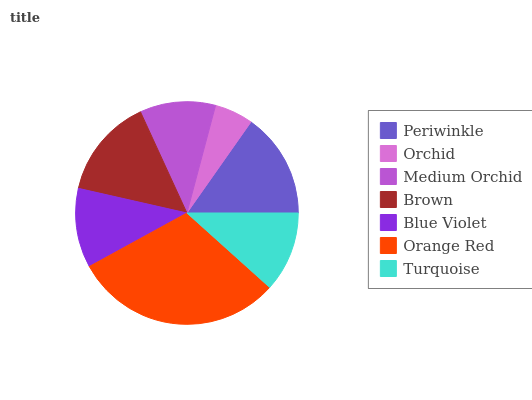Is Orchid the minimum?
Answer yes or no. Yes. Is Orange Red the maximum?
Answer yes or no. Yes. Is Medium Orchid the minimum?
Answer yes or no. No. Is Medium Orchid the maximum?
Answer yes or no. No. Is Medium Orchid greater than Orchid?
Answer yes or no. Yes. Is Orchid less than Medium Orchid?
Answer yes or no. Yes. Is Orchid greater than Medium Orchid?
Answer yes or no. No. Is Medium Orchid less than Orchid?
Answer yes or no. No. Is Turquoise the high median?
Answer yes or no. Yes. Is Turquoise the low median?
Answer yes or no. Yes. Is Blue Violet the high median?
Answer yes or no. No. Is Blue Violet the low median?
Answer yes or no. No. 